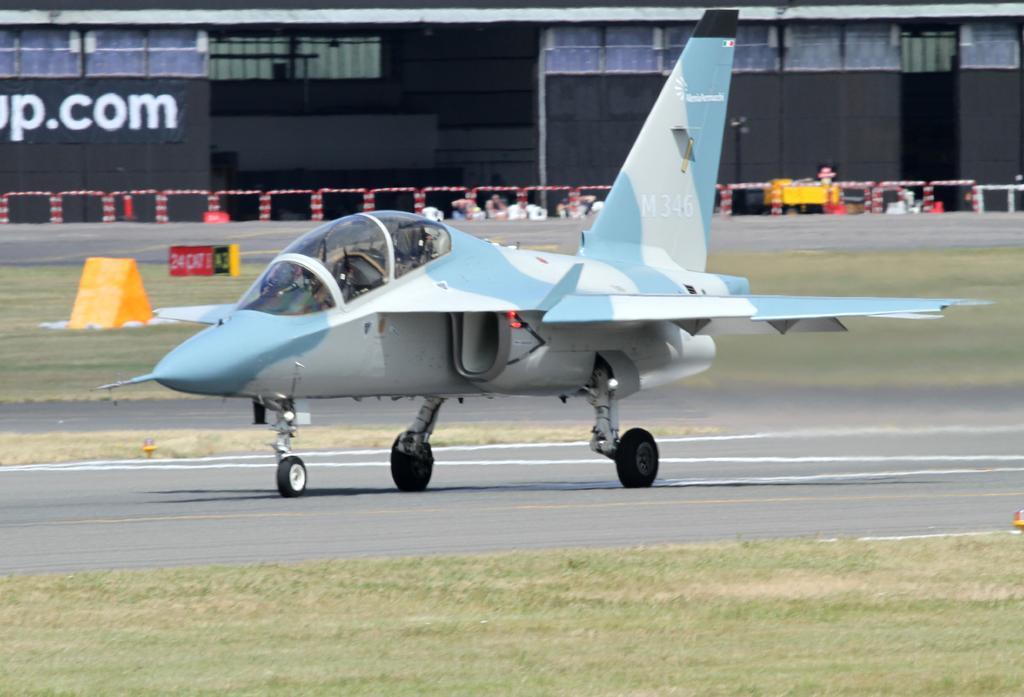Describe this image in one or two sentences. In this image I can see a road and on it I can see white lines and an aircraft. I can also see grass, a building, few yellow colour things, a red colour board and here I can see something is written. 